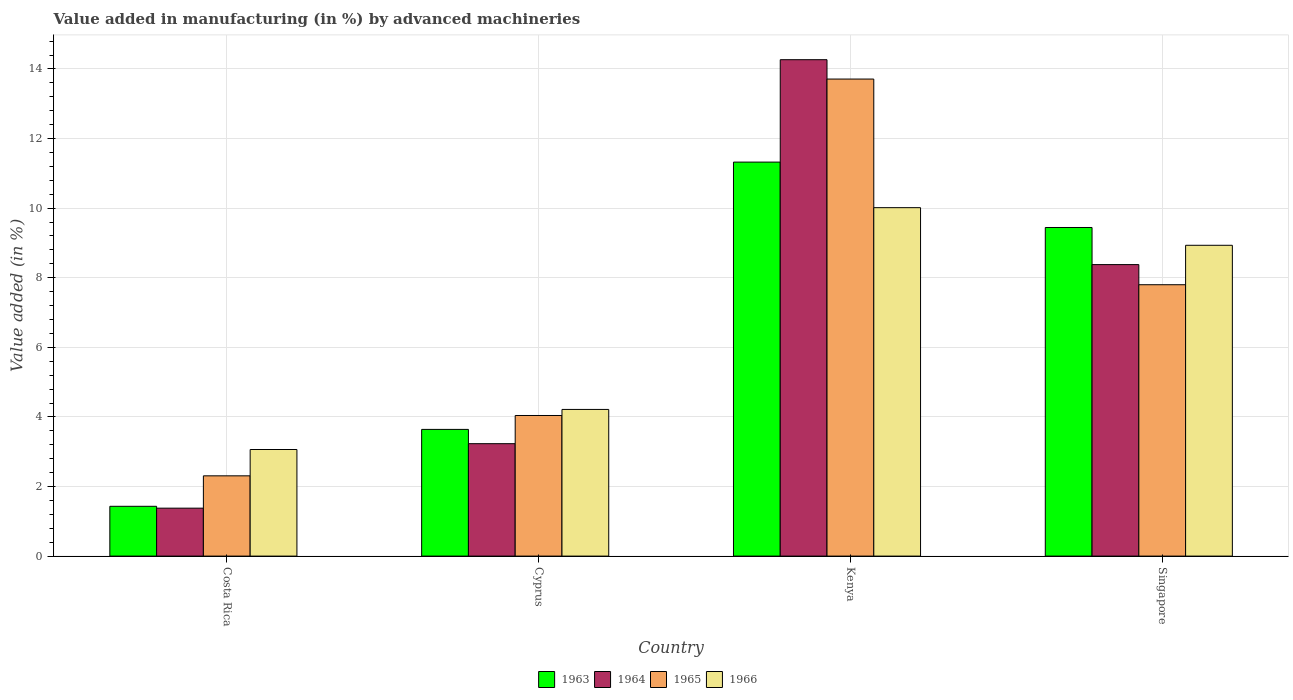How many different coloured bars are there?
Offer a very short reply. 4. How many groups of bars are there?
Give a very brief answer. 4. Are the number of bars per tick equal to the number of legend labels?
Keep it short and to the point. Yes. How many bars are there on the 1st tick from the left?
Your answer should be very brief. 4. What is the label of the 2nd group of bars from the left?
Keep it short and to the point. Cyprus. In how many cases, is the number of bars for a given country not equal to the number of legend labels?
Provide a succinct answer. 0. What is the percentage of value added in manufacturing by advanced machineries in 1966 in Costa Rica?
Your response must be concise. 3.06. Across all countries, what is the maximum percentage of value added in manufacturing by advanced machineries in 1965?
Offer a very short reply. 13.71. Across all countries, what is the minimum percentage of value added in manufacturing by advanced machineries in 1965?
Your answer should be very brief. 2.31. In which country was the percentage of value added in manufacturing by advanced machineries in 1963 maximum?
Keep it short and to the point. Kenya. What is the total percentage of value added in manufacturing by advanced machineries in 1966 in the graph?
Give a very brief answer. 26.23. What is the difference between the percentage of value added in manufacturing by advanced machineries in 1963 in Cyprus and that in Singapore?
Offer a very short reply. -5.8. What is the difference between the percentage of value added in manufacturing by advanced machineries in 1964 in Singapore and the percentage of value added in manufacturing by advanced machineries in 1963 in Cyprus?
Keep it short and to the point. 4.74. What is the average percentage of value added in manufacturing by advanced machineries in 1965 per country?
Your answer should be very brief. 6.96. What is the difference between the percentage of value added in manufacturing by advanced machineries of/in 1963 and percentage of value added in manufacturing by advanced machineries of/in 1966 in Singapore?
Offer a terse response. 0.51. In how many countries, is the percentage of value added in manufacturing by advanced machineries in 1963 greater than 8.8 %?
Provide a succinct answer. 2. What is the ratio of the percentage of value added in manufacturing by advanced machineries in 1963 in Costa Rica to that in Kenya?
Provide a short and direct response. 0.13. Is the difference between the percentage of value added in manufacturing by advanced machineries in 1963 in Costa Rica and Kenya greater than the difference between the percentage of value added in manufacturing by advanced machineries in 1966 in Costa Rica and Kenya?
Your answer should be compact. No. What is the difference between the highest and the second highest percentage of value added in manufacturing by advanced machineries in 1964?
Give a very brief answer. 5.15. What is the difference between the highest and the lowest percentage of value added in manufacturing by advanced machineries in 1964?
Provide a succinct answer. 12.89. Is it the case that in every country, the sum of the percentage of value added in manufacturing by advanced machineries in 1965 and percentage of value added in manufacturing by advanced machineries in 1966 is greater than the sum of percentage of value added in manufacturing by advanced machineries in 1964 and percentage of value added in manufacturing by advanced machineries in 1963?
Make the answer very short. No. What does the 2nd bar from the left in Cyprus represents?
Give a very brief answer. 1964. What does the 4th bar from the right in Singapore represents?
Ensure brevity in your answer.  1963. Is it the case that in every country, the sum of the percentage of value added in manufacturing by advanced machineries in 1964 and percentage of value added in manufacturing by advanced machineries in 1966 is greater than the percentage of value added in manufacturing by advanced machineries in 1963?
Give a very brief answer. Yes. Are all the bars in the graph horizontal?
Your response must be concise. No. How many countries are there in the graph?
Keep it short and to the point. 4. What is the difference between two consecutive major ticks on the Y-axis?
Your response must be concise. 2. Does the graph contain grids?
Ensure brevity in your answer.  Yes. Where does the legend appear in the graph?
Provide a short and direct response. Bottom center. How are the legend labels stacked?
Make the answer very short. Horizontal. What is the title of the graph?
Ensure brevity in your answer.  Value added in manufacturing (in %) by advanced machineries. Does "1996" appear as one of the legend labels in the graph?
Provide a short and direct response. No. What is the label or title of the X-axis?
Keep it short and to the point. Country. What is the label or title of the Y-axis?
Your response must be concise. Value added (in %). What is the Value added (in %) in 1963 in Costa Rica?
Provide a short and direct response. 1.43. What is the Value added (in %) in 1964 in Costa Rica?
Offer a terse response. 1.38. What is the Value added (in %) in 1965 in Costa Rica?
Keep it short and to the point. 2.31. What is the Value added (in %) in 1966 in Costa Rica?
Your answer should be very brief. 3.06. What is the Value added (in %) in 1963 in Cyprus?
Offer a very short reply. 3.64. What is the Value added (in %) in 1964 in Cyprus?
Ensure brevity in your answer.  3.23. What is the Value added (in %) of 1965 in Cyprus?
Ensure brevity in your answer.  4.04. What is the Value added (in %) of 1966 in Cyprus?
Ensure brevity in your answer.  4.22. What is the Value added (in %) of 1963 in Kenya?
Your answer should be compact. 11.32. What is the Value added (in %) of 1964 in Kenya?
Provide a short and direct response. 14.27. What is the Value added (in %) of 1965 in Kenya?
Provide a succinct answer. 13.71. What is the Value added (in %) in 1966 in Kenya?
Make the answer very short. 10.01. What is the Value added (in %) in 1963 in Singapore?
Your answer should be compact. 9.44. What is the Value added (in %) in 1964 in Singapore?
Provide a short and direct response. 8.38. What is the Value added (in %) of 1965 in Singapore?
Provide a succinct answer. 7.8. What is the Value added (in %) in 1966 in Singapore?
Your answer should be very brief. 8.93. Across all countries, what is the maximum Value added (in %) of 1963?
Give a very brief answer. 11.32. Across all countries, what is the maximum Value added (in %) of 1964?
Offer a terse response. 14.27. Across all countries, what is the maximum Value added (in %) of 1965?
Make the answer very short. 13.71. Across all countries, what is the maximum Value added (in %) in 1966?
Make the answer very short. 10.01. Across all countries, what is the minimum Value added (in %) of 1963?
Provide a short and direct response. 1.43. Across all countries, what is the minimum Value added (in %) of 1964?
Give a very brief answer. 1.38. Across all countries, what is the minimum Value added (in %) in 1965?
Provide a short and direct response. 2.31. Across all countries, what is the minimum Value added (in %) of 1966?
Make the answer very short. 3.06. What is the total Value added (in %) of 1963 in the graph?
Ensure brevity in your answer.  25.84. What is the total Value added (in %) in 1964 in the graph?
Provide a succinct answer. 27.25. What is the total Value added (in %) in 1965 in the graph?
Your answer should be very brief. 27.86. What is the total Value added (in %) of 1966 in the graph?
Keep it short and to the point. 26.23. What is the difference between the Value added (in %) in 1963 in Costa Rica and that in Cyprus?
Provide a succinct answer. -2.21. What is the difference between the Value added (in %) in 1964 in Costa Rica and that in Cyprus?
Keep it short and to the point. -1.85. What is the difference between the Value added (in %) in 1965 in Costa Rica and that in Cyprus?
Ensure brevity in your answer.  -1.73. What is the difference between the Value added (in %) of 1966 in Costa Rica and that in Cyprus?
Give a very brief answer. -1.15. What is the difference between the Value added (in %) of 1963 in Costa Rica and that in Kenya?
Your response must be concise. -9.89. What is the difference between the Value added (in %) in 1964 in Costa Rica and that in Kenya?
Provide a short and direct response. -12.89. What is the difference between the Value added (in %) of 1965 in Costa Rica and that in Kenya?
Your answer should be very brief. -11.4. What is the difference between the Value added (in %) of 1966 in Costa Rica and that in Kenya?
Provide a short and direct response. -6.95. What is the difference between the Value added (in %) of 1963 in Costa Rica and that in Singapore?
Offer a very short reply. -8.01. What is the difference between the Value added (in %) in 1964 in Costa Rica and that in Singapore?
Keep it short and to the point. -7. What is the difference between the Value added (in %) in 1965 in Costa Rica and that in Singapore?
Provide a succinct answer. -5.49. What is the difference between the Value added (in %) in 1966 in Costa Rica and that in Singapore?
Your response must be concise. -5.87. What is the difference between the Value added (in %) in 1963 in Cyprus and that in Kenya?
Ensure brevity in your answer.  -7.68. What is the difference between the Value added (in %) of 1964 in Cyprus and that in Kenya?
Offer a very short reply. -11.04. What is the difference between the Value added (in %) in 1965 in Cyprus and that in Kenya?
Offer a very short reply. -9.67. What is the difference between the Value added (in %) of 1966 in Cyprus and that in Kenya?
Your answer should be very brief. -5.8. What is the difference between the Value added (in %) of 1963 in Cyprus and that in Singapore?
Your response must be concise. -5.8. What is the difference between the Value added (in %) in 1964 in Cyprus and that in Singapore?
Your answer should be compact. -5.15. What is the difference between the Value added (in %) in 1965 in Cyprus and that in Singapore?
Your answer should be compact. -3.76. What is the difference between the Value added (in %) of 1966 in Cyprus and that in Singapore?
Provide a short and direct response. -4.72. What is the difference between the Value added (in %) of 1963 in Kenya and that in Singapore?
Make the answer very short. 1.88. What is the difference between the Value added (in %) in 1964 in Kenya and that in Singapore?
Provide a short and direct response. 5.89. What is the difference between the Value added (in %) of 1965 in Kenya and that in Singapore?
Keep it short and to the point. 5.91. What is the difference between the Value added (in %) in 1966 in Kenya and that in Singapore?
Provide a short and direct response. 1.08. What is the difference between the Value added (in %) in 1963 in Costa Rica and the Value added (in %) in 1964 in Cyprus?
Ensure brevity in your answer.  -1.8. What is the difference between the Value added (in %) of 1963 in Costa Rica and the Value added (in %) of 1965 in Cyprus?
Offer a terse response. -2.61. What is the difference between the Value added (in %) in 1963 in Costa Rica and the Value added (in %) in 1966 in Cyprus?
Provide a short and direct response. -2.78. What is the difference between the Value added (in %) of 1964 in Costa Rica and the Value added (in %) of 1965 in Cyprus?
Offer a very short reply. -2.66. What is the difference between the Value added (in %) of 1964 in Costa Rica and the Value added (in %) of 1966 in Cyprus?
Your answer should be very brief. -2.84. What is the difference between the Value added (in %) in 1965 in Costa Rica and the Value added (in %) in 1966 in Cyprus?
Offer a terse response. -1.91. What is the difference between the Value added (in %) of 1963 in Costa Rica and the Value added (in %) of 1964 in Kenya?
Ensure brevity in your answer.  -12.84. What is the difference between the Value added (in %) of 1963 in Costa Rica and the Value added (in %) of 1965 in Kenya?
Ensure brevity in your answer.  -12.28. What is the difference between the Value added (in %) of 1963 in Costa Rica and the Value added (in %) of 1966 in Kenya?
Make the answer very short. -8.58. What is the difference between the Value added (in %) in 1964 in Costa Rica and the Value added (in %) in 1965 in Kenya?
Offer a terse response. -12.33. What is the difference between the Value added (in %) of 1964 in Costa Rica and the Value added (in %) of 1966 in Kenya?
Provide a short and direct response. -8.64. What is the difference between the Value added (in %) of 1965 in Costa Rica and the Value added (in %) of 1966 in Kenya?
Offer a terse response. -7.71. What is the difference between the Value added (in %) of 1963 in Costa Rica and the Value added (in %) of 1964 in Singapore?
Keep it short and to the point. -6.95. What is the difference between the Value added (in %) in 1963 in Costa Rica and the Value added (in %) in 1965 in Singapore?
Keep it short and to the point. -6.37. What is the difference between the Value added (in %) of 1963 in Costa Rica and the Value added (in %) of 1966 in Singapore?
Offer a very short reply. -7.5. What is the difference between the Value added (in %) of 1964 in Costa Rica and the Value added (in %) of 1965 in Singapore?
Give a very brief answer. -6.42. What is the difference between the Value added (in %) in 1964 in Costa Rica and the Value added (in %) in 1966 in Singapore?
Your answer should be compact. -7.55. What is the difference between the Value added (in %) of 1965 in Costa Rica and the Value added (in %) of 1966 in Singapore?
Provide a succinct answer. -6.63. What is the difference between the Value added (in %) in 1963 in Cyprus and the Value added (in %) in 1964 in Kenya?
Your answer should be very brief. -10.63. What is the difference between the Value added (in %) in 1963 in Cyprus and the Value added (in %) in 1965 in Kenya?
Your response must be concise. -10.07. What is the difference between the Value added (in %) in 1963 in Cyprus and the Value added (in %) in 1966 in Kenya?
Give a very brief answer. -6.37. What is the difference between the Value added (in %) in 1964 in Cyprus and the Value added (in %) in 1965 in Kenya?
Ensure brevity in your answer.  -10.48. What is the difference between the Value added (in %) of 1964 in Cyprus and the Value added (in %) of 1966 in Kenya?
Your response must be concise. -6.78. What is the difference between the Value added (in %) of 1965 in Cyprus and the Value added (in %) of 1966 in Kenya?
Ensure brevity in your answer.  -5.97. What is the difference between the Value added (in %) of 1963 in Cyprus and the Value added (in %) of 1964 in Singapore?
Provide a short and direct response. -4.74. What is the difference between the Value added (in %) in 1963 in Cyprus and the Value added (in %) in 1965 in Singapore?
Provide a succinct answer. -4.16. What is the difference between the Value added (in %) of 1963 in Cyprus and the Value added (in %) of 1966 in Singapore?
Give a very brief answer. -5.29. What is the difference between the Value added (in %) of 1964 in Cyprus and the Value added (in %) of 1965 in Singapore?
Your answer should be compact. -4.57. What is the difference between the Value added (in %) of 1964 in Cyprus and the Value added (in %) of 1966 in Singapore?
Provide a short and direct response. -5.7. What is the difference between the Value added (in %) in 1965 in Cyprus and the Value added (in %) in 1966 in Singapore?
Your answer should be compact. -4.89. What is the difference between the Value added (in %) of 1963 in Kenya and the Value added (in %) of 1964 in Singapore?
Your answer should be very brief. 2.95. What is the difference between the Value added (in %) in 1963 in Kenya and the Value added (in %) in 1965 in Singapore?
Your answer should be compact. 3.52. What is the difference between the Value added (in %) of 1963 in Kenya and the Value added (in %) of 1966 in Singapore?
Your response must be concise. 2.39. What is the difference between the Value added (in %) of 1964 in Kenya and the Value added (in %) of 1965 in Singapore?
Make the answer very short. 6.47. What is the difference between the Value added (in %) of 1964 in Kenya and the Value added (in %) of 1966 in Singapore?
Offer a terse response. 5.33. What is the difference between the Value added (in %) in 1965 in Kenya and the Value added (in %) in 1966 in Singapore?
Offer a terse response. 4.78. What is the average Value added (in %) of 1963 per country?
Ensure brevity in your answer.  6.46. What is the average Value added (in %) of 1964 per country?
Keep it short and to the point. 6.81. What is the average Value added (in %) of 1965 per country?
Make the answer very short. 6.96. What is the average Value added (in %) in 1966 per country?
Keep it short and to the point. 6.56. What is the difference between the Value added (in %) of 1963 and Value added (in %) of 1964 in Costa Rica?
Your answer should be very brief. 0.05. What is the difference between the Value added (in %) of 1963 and Value added (in %) of 1965 in Costa Rica?
Offer a terse response. -0.88. What is the difference between the Value added (in %) in 1963 and Value added (in %) in 1966 in Costa Rica?
Ensure brevity in your answer.  -1.63. What is the difference between the Value added (in %) of 1964 and Value added (in %) of 1965 in Costa Rica?
Offer a terse response. -0.93. What is the difference between the Value added (in %) of 1964 and Value added (in %) of 1966 in Costa Rica?
Keep it short and to the point. -1.69. What is the difference between the Value added (in %) of 1965 and Value added (in %) of 1966 in Costa Rica?
Offer a terse response. -0.76. What is the difference between the Value added (in %) of 1963 and Value added (in %) of 1964 in Cyprus?
Give a very brief answer. 0.41. What is the difference between the Value added (in %) of 1963 and Value added (in %) of 1965 in Cyprus?
Give a very brief answer. -0.4. What is the difference between the Value added (in %) in 1963 and Value added (in %) in 1966 in Cyprus?
Provide a succinct answer. -0.57. What is the difference between the Value added (in %) in 1964 and Value added (in %) in 1965 in Cyprus?
Offer a terse response. -0.81. What is the difference between the Value added (in %) in 1964 and Value added (in %) in 1966 in Cyprus?
Make the answer very short. -0.98. What is the difference between the Value added (in %) in 1965 and Value added (in %) in 1966 in Cyprus?
Your answer should be very brief. -0.17. What is the difference between the Value added (in %) of 1963 and Value added (in %) of 1964 in Kenya?
Give a very brief answer. -2.94. What is the difference between the Value added (in %) in 1963 and Value added (in %) in 1965 in Kenya?
Give a very brief answer. -2.39. What is the difference between the Value added (in %) in 1963 and Value added (in %) in 1966 in Kenya?
Keep it short and to the point. 1.31. What is the difference between the Value added (in %) in 1964 and Value added (in %) in 1965 in Kenya?
Make the answer very short. 0.56. What is the difference between the Value added (in %) of 1964 and Value added (in %) of 1966 in Kenya?
Offer a very short reply. 4.25. What is the difference between the Value added (in %) in 1965 and Value added (in %) in 1966 in Kenya?
Your response must be concise. 3.7. What is the difference between the Value added (in %) of 1963 and Value added (in %) of 1964 in Singapore?
Ensure brevity in your answer.  1.07. What is the difference between the Value added (in %) of 1963 and Value added (in %) of 1965 in Singapore?
Provide a short and direct response. 1.64. What is the difference between the Value added (in %) of 1963 and Value added (in %) of 1966 in Singapore?
Provide a short and direct response. 0.51. What is the difference between the Value added (in %) in 1964 and Value added (in %) in 1965 in Singapore?
Provide a short and direct response. 0.58. What is the difference between the Value added (in %) of 1964 and Value added (in %) of 1966 in Singapore?
Your response must be concise. -0.55. What is the difference between the Value added (in %) of 1965 and Value added (in %) of 1966 in Singapore?
Offer a terse response. -1.13. What is the ratio of the Value added (in %) in 1963 in Costa Rica to that in Cyprus?
Provide a succinct answer. 0.39. What is the ratio of the Value added (in %) in 1964 in Costa Rica to that in Cyprus?
Make the answer very short. 0.43. What is the ratio of the Value added (in %) in 1965 in Costa Rica to that in Cyprus?
Give a very brief answer. 0.57. What is the ratio of the Value added (in %) of 1966 in Costa Rica to that in Cyprus?
Ensure brevity in your answer.  0.73. What is the ratio of the Value added (in %) in 1963 in Costa Rica to that in Kenya?
Make the answer very short. 0.13. What is the ratio of the Value added (in %) in 1964 in Costa Rica to that in Kenya?
Make the answer very short. 0.1. What is the ratio of the Value added (in %) in 1965 in Costa Rica to that in Kenya?
Give a very brief answer. 0.17. What is the ratio of the Value added (in %) of 1966 in Costa Rica to that in Kenya?
Offer a very short reply. 0.31. What is the ratio of the Value added (in %) in 1963 in Costa Rica to that in Singapore?
Keep it short and to the point. 0.15. What is the ratio of the Value added (in %) in 1964 in Costa Rica to that in Singapore?
Give a very brief answer. 0.16. What is the ratio of the Value added (in %) in 1965 in Costa Rica to that in Singapore?
Offer a terse response. 0.3. What is the ratio of the Value added (in %) in 1966 in Costa Rica to that in Singapore?
Ensure brevity in your answer.  0.34. What is the ratio of the Value added (in %) in 1963 in Cyprus to that in Kenya?
Provide a succinct answer. 0.32. What is the ratio of the Value added (in %) in 1964 in Cyprus to that in Kenya?
Ensure brevity in your answer.  0.23. What is the ratio of the Value added (in %) of 1965 in Cyprus to that in Kenya?
Keep it short and to the point. 0.29. What is the ratio of the Value added (in %) of 1966 in Cyprus to that in Kenya?
Provide a short and direct response. 0.42. What is the ratio of the Value added (in %) of 1963 in Cyprus to that in Singapore?
Offer a terse response. 0.39. What is the ratio of the Value added (in %) in 1964 in Cyprus to that in Singapore?
Offer a very short reply. 0.39. What is the ratio of the Value added (in %) of 1965 in Cyprus to that in Singapore?
Your answer should be very brief. 0.52. What is the ratio of the Value added (in %) of 1966 in Cyprus to that in Singapore?
Offer a very short reply. 0.47. What is the ratio of the Value added (in %) in 1963 in Kenya to that in Singapore?
Give a very brief answer. 1.2. What is the ratio of the Value added (in %) in 1964 in Kenya to that in Singapore?
Provide a short and direct response. 1.7. What is the ratio of the Value added (in %) in 1965 in Kenya to that in Singapore?
Your response must be concise. 1.76. What is the ratio of the Value added (in %) of 1966 in Kenya to that in Singapore?
Your answer should be very brief. 1.12. What is the difference between the highest and the second highest Value added (in %) of 1963?
Keep it short and to the point. 1.88. What is the difference between the highest and the second highest Value added (in %) of 1964?
Make the answer very short. 5.89. What is the difference between the highest and the second highest Value added (in %) of 1965?
Your answer should be compact. 5.91. What is the difference between the highest and the second highest Value added (in %) in 1966?
Provide a short and direct response. 1.08. What is the difference between the highest and the lowest Value added (in %) of 1963?
Give a very brief answer. 9.89. What is the difference between the highest and the lowest Value added (in %) in 1964?
Provide a succinct answer. 12.89. What is the difference between the highest and the lowest Value added (in %) of 1965?
Provide a succinct answer. 11.4. What is the difference between the highest and the lowest Value added (in %) in 1966?
Your answer should be compact. 6.95. 